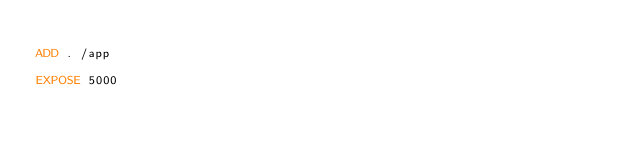Convert code to text. <code><loc_0><loc_0><loc_500><loc_500><_Dockerfile_>
ADD . /app

EXPOSE 5000
</code> 